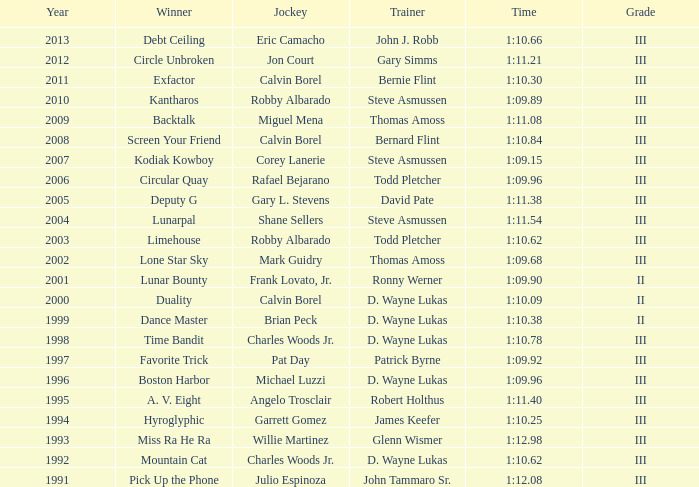What was the time for Screen Your Friend? 1:10.84. 